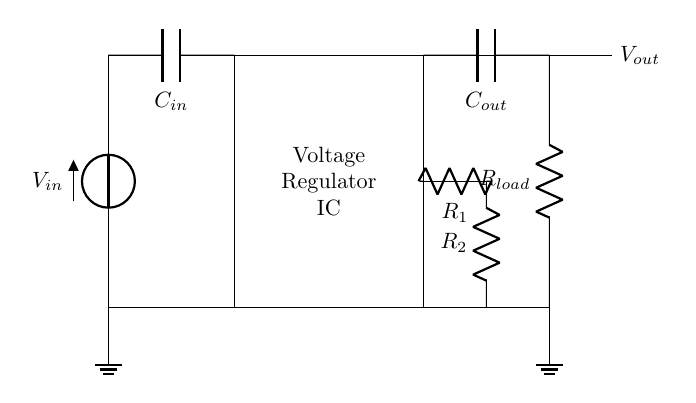What is the input voltage of the circuit? The input voltage, labeled as V_in, is indicated next to the voltage source at the component's position.
Answer: V_in What is the output voltage of the circuit? The output voltage, labeled as V_out, is shown next to the output capacitor and load resistor, indicating the stabilized voltage provided to the load.
Answer: V_out What type of circuit is this? This is a voltage regulator circuit because it includes an integrated circuit designed to maintain a constant output voltage regardless of variations in input voltage or load conditions.
Answer: Voltage regulator What are the output capacitor and load resistor in series? The output capacitor (C_out) and load resistor (R_load) are connected in series since the current must pass through both components sequentially before returning to ground.
Answer: Yes How many feedback resistors are present in the circuit? There are two feedback resistors, identified as R_1 and R_2, which help set the output voltage and create a feedback loop for the voltage regulation process.
Answer: Two What is the purpose of the input capacitor? The input capacitor (C_in) is used to filter out voltage spikes or noise from the input power supply, ensuring stable operation of the voltage regulator circuit.
Answer: To filter noise 